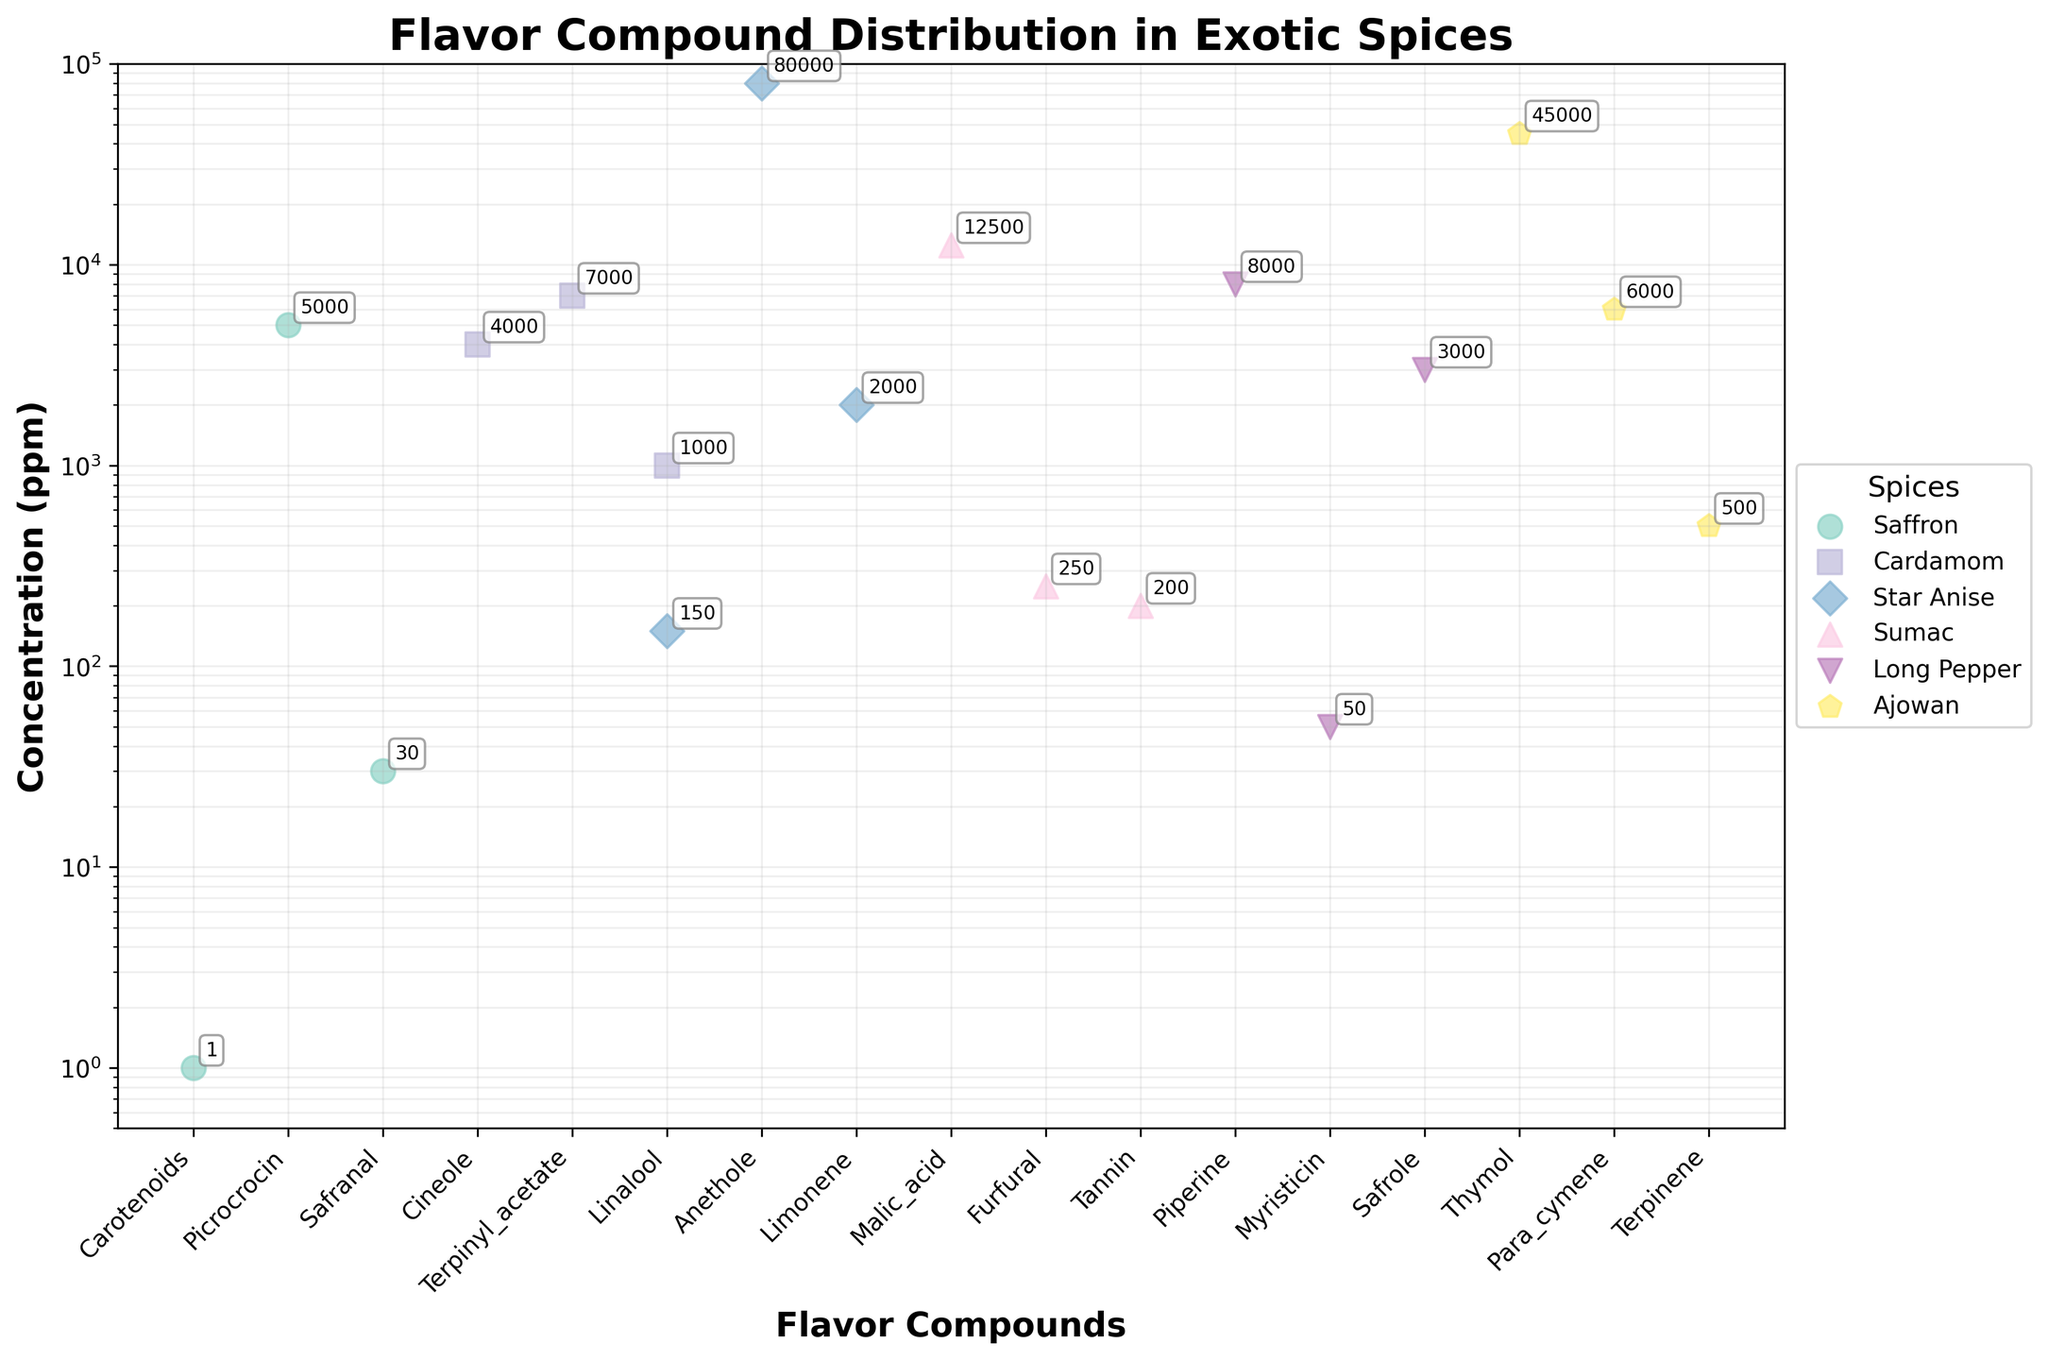What is the title of the plot? The title is located at the top of the figure, usually larger and bold to distinguish it from other text. The title of the plot is "Flavor Compound Distribution in Exotic Spices".
Answer: Flavor Compound Distribution in Exotic Spices Which spice has the highest concentration of any flavor compound, and what is it? By examining the y-axis values and the data points, the highest concentration is for Star Anise with the compound Anethole, having a concentration of 80000 ppm.
Answer: Star Anise, Anethole How many flavor compounds are shown for Saffron? Each marker represents a flavor compound, and Saffron has three markers: Carotenoids, Picrocrocin, and Safranal.
Answer: 3 What is the range of concentrations for Ajowan flavor compounds? The concentrations for Ajowan are found by noting the highest and lowest values among its compounds. Thymol is at 45000 ppm, Para_cymene is 6000 ppm, and Terpinene is 500 ppm, resulting in a range from 500 to 45000.
Answer: 500 to 45000 Identify the spice with the lowest concentration flavor compound and its corresponding compound. By locating the smallest value on the y-axis, the lowest concentration is 1 ppm for Saffron's Carotenoids.
Answer: Saffron, Carotenoids Which spice has the widest range of flavor compound concentrations? To determine this, compare the highest and lowest concentrations within each spice. Star Anise ranges from 150 to 80000 ppm, which is the widest range.
Answer: Star Anise How does the concentration of Piperine in Long Pepper compare to the concentration of Thymol in Ajowan? Piperine in Long Pepper has a concentration of 8000 ppm, while Thymol in Ajowan has a concentration of 45000 ppm, making Thymol in Ajowan higher than Piperine in Long Pepper.
Answer: Thymol in Ajowan is higher Is there any spice that has all its flavor compounds with concentrations above 1000 ppm? By examining each spice: Saffron has Carotenoids at 1 ppm, so it's not Saffron; however, Ajowan has all its compounds (Thymol, Para_cymene, Terpinene) above 1000 ppm (45000, 6000, and 500), so no, none qualify completely.
Answer: No Which flavor compound in the plot has the highest concentration? Anethole in Star Anise has the highest value on the y-axis among all compounds, which is 80000 ppm.
Answer: Anethole in Star Anise What is the average concentration of the flavor compounds in Sumac? The concentrations for Sumac are 12500, 250, and 200 ppm. Sum the concentrations (12500 + 250 + 200 = 12950) and divide by the number of compounds (3) to find the average: 12950 / 3 ≈ 4317 ppm.
Answer: Around 4317 ppm 